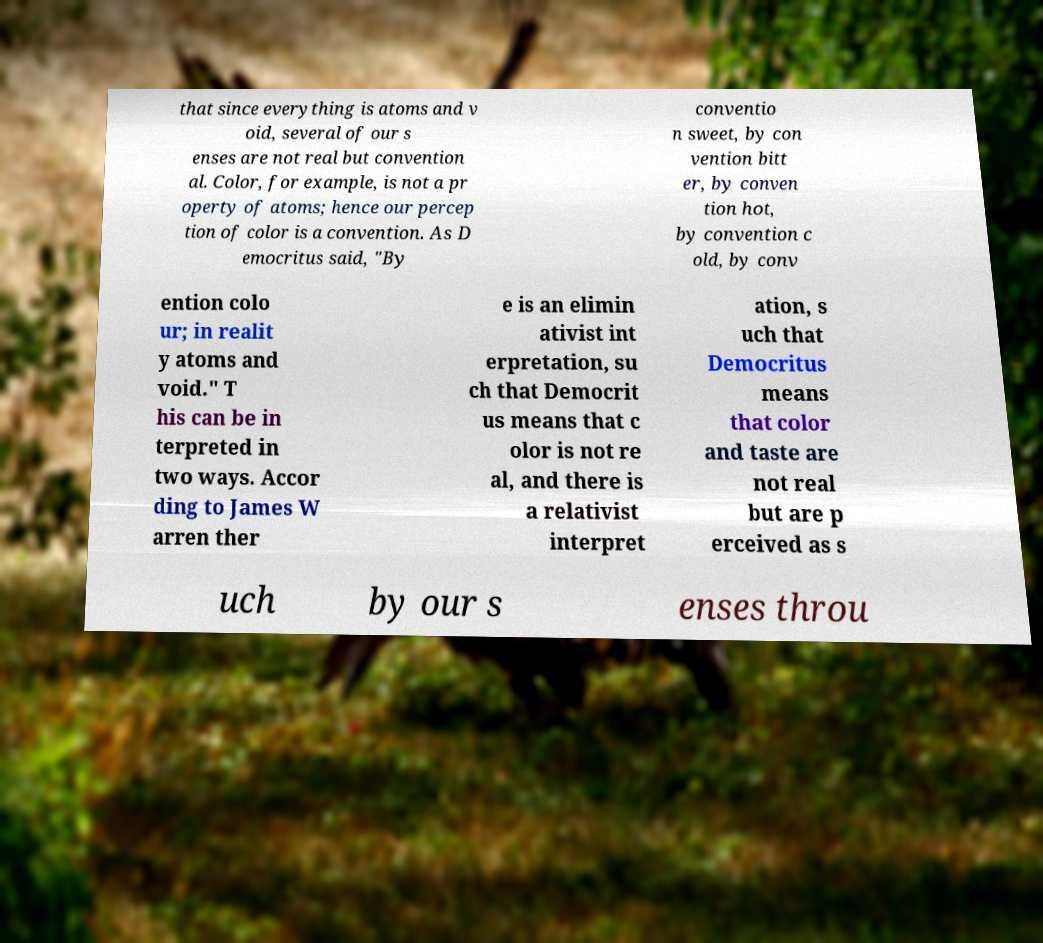Could you assist in decoding the text presented in this image and type it out clearly? that since everything is atoms and v oid, several of our s enses are not real but convention al. Color, for example, is not a pr operty of atoms; hence our percep tion of color is a convention. As D emocritus said, "By conventio n sweet, by con vention bitt er, by conven tion hot, by convention c old, by conv ention colo ur; in realit y atoms and void." T his can be in terpreted in two ways. Accor ding to James W arren ther e is an elimin ativist int erpretation, su ch that Democrit us means that c olor is not re al, and there is a relativist interpret ation, s uch that Democritus means that color and taste are not real but are p erceived as s uch by our s enses throu 